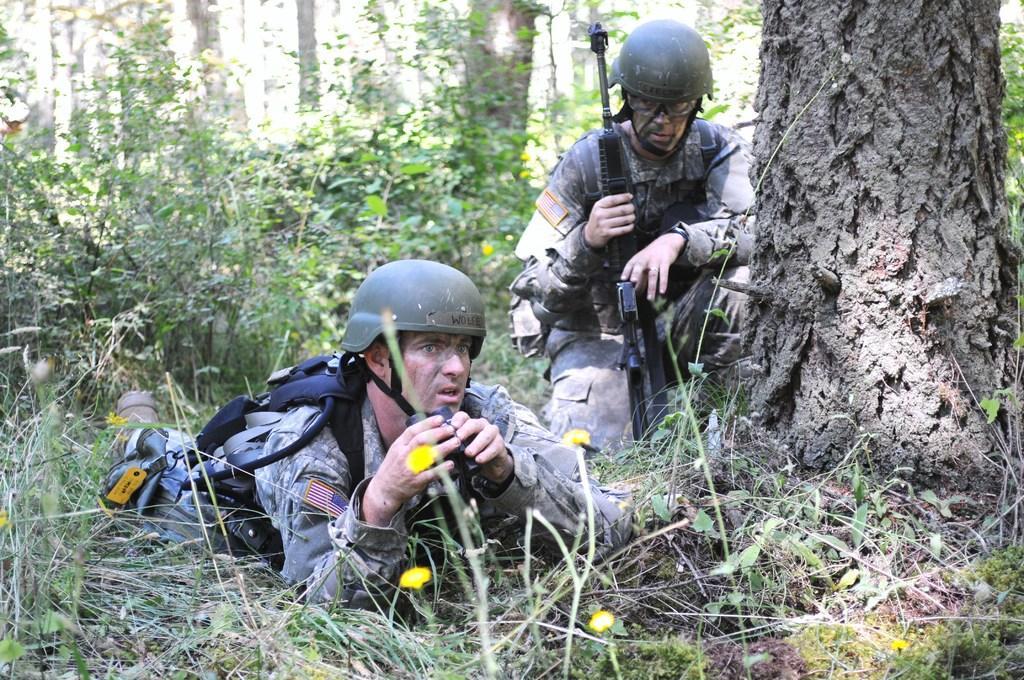Describe this image in one or two sentences. In this image I can see two men among them one man is lying on the ground and one man is kneeling down on the ground. These people are wearing uniforms, helmets and carrying some objects. In the background I can see plants, grass, trees and other objects on the ground. 